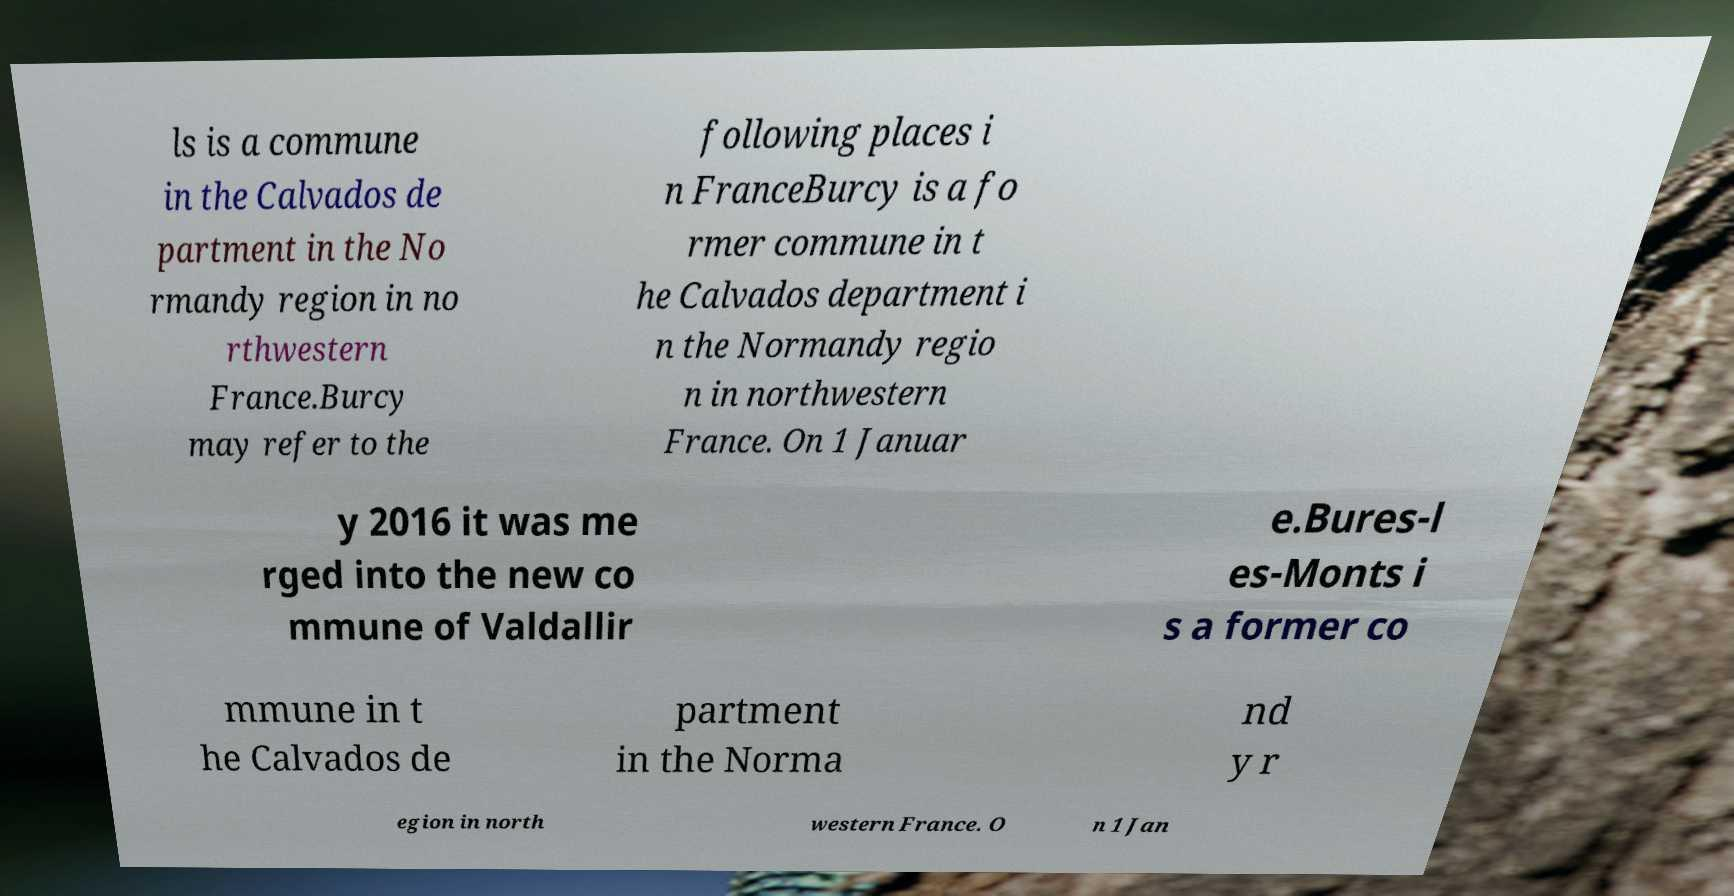Can you read and provide the text displayed in the image?This photo seems to have some interesting text. Can you extract and type it out for me? ls is a commune in the Calvados de partment in the No rmandy region in no rthwestern France.Burcy may refer to the following places i n FranceBurcy is a fo rmer commune in t he Calvados department i n the Normandy regio n in northwestern France. On 1 Januar y 2016 it was me rged into the new co mmune of Valdallir e.Bures-l es-Monts i s a former co mmune in t he Calvados de partment in the Norma nd y r egion in north western France. O n 1 Jan 